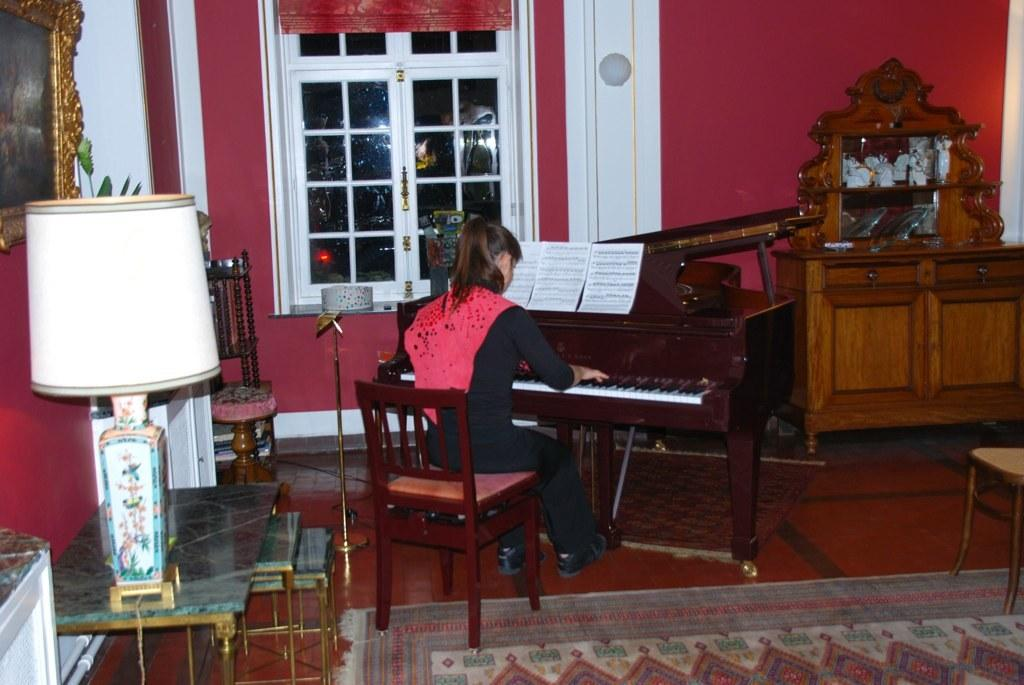What is the person in the image doing? The person is sitting in front of a piano. What object is to the left of the person? There is a lamp to the left of the person. What can be seen in the background of the image? There is a window in the background. What type of jam is being spread on the truck in the image? There is no truck or jam present in the image. Can you describe the kitten playing with the piano keys in the image? There is no kitten present in the image; the person is the only one interacting with the piano. 